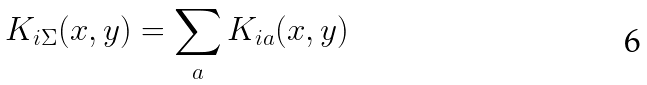<formula> <loc_0><loc_0><loc_500><loc_500>K _ { i \Sigma } ( x , y ) = \sum _ { a } K _ { i a } ( x , y )</formula> 